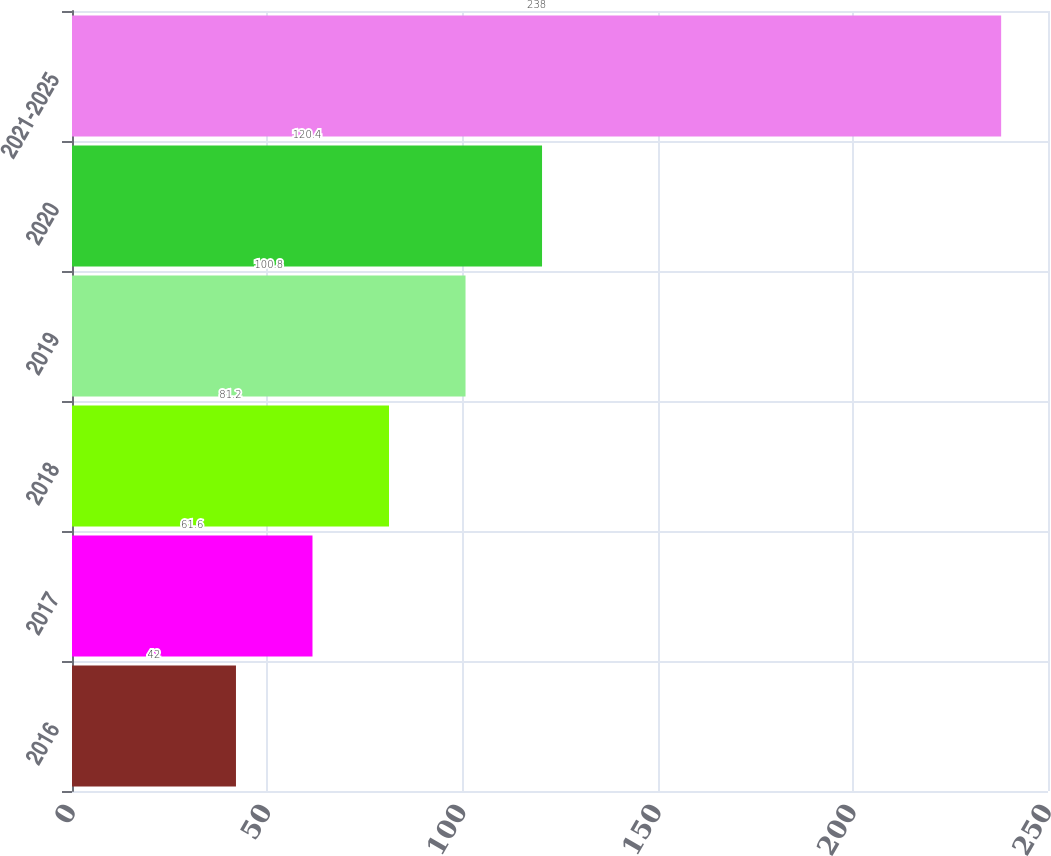Convert chart to OTSL. <chart><loc_0><loc_0><loc_500><loc_500><bar_chart><fcel>2016<fcel>2017<fcel>2018<fcel>2019<fcel>2020<fcel>2021-2025<nl><fcel>42<fcel>61.6<fcel>81.2<fcel>100.8<fcel>120.4<fcel>238<nl></chart> 